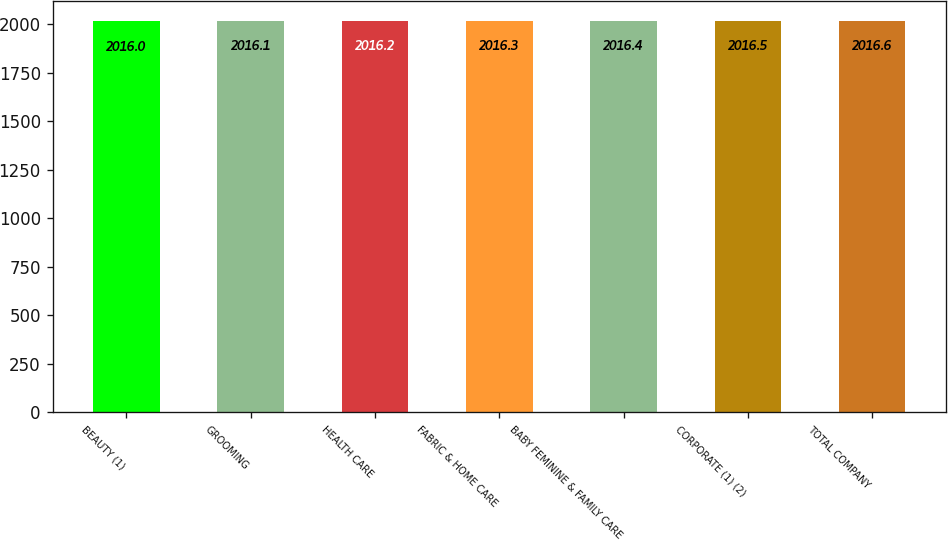Convert chart to OTSL. <chart><loc_0><loc_0><loc_500><loc_500><bar_chart><fcel>BEAUTY (1)<fcel>GROOMING<fcel>HEALTH CARE<fcel>FABRIC & HOME CARE<fcel>BABY FEMININE & FAMILY CARE<fcel>CORPORATE (1) (2)<fcel>TOTAL COMPANY<nl><fcel>2016<fcel>2016.1<fcel>2016.2<fcel>2016.3<fcel>2016.4<fcel>2016.5<fcel>2016.6<nl></chart> 